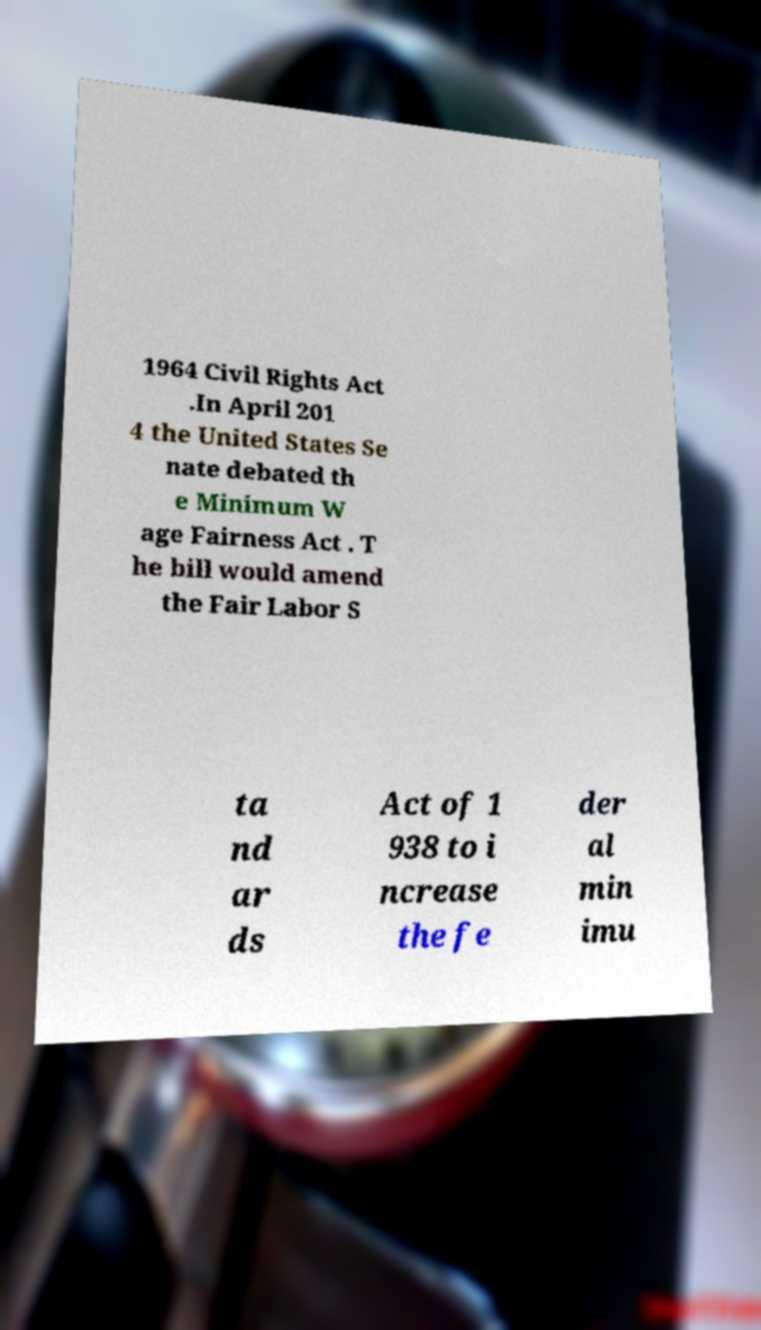What messages or text are displayed in this image? I need them in a readable, typed format. 1964 Civil Rights Act .In April 201 4 the United States Se nate debated th e Minimum W age Fairness Act . T he bill would amend the Fair Labor S ta nd ar ds Act of 1 938 to i ncrease the fe der al min imu 